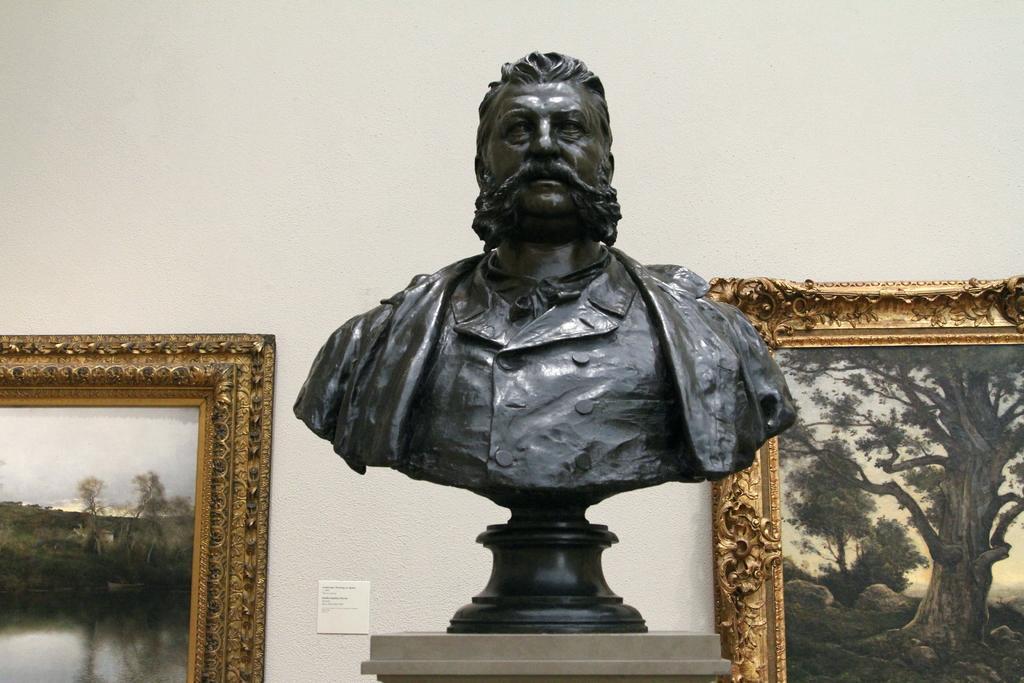Could you give a brief overview of what you see in this image? In this image we can see a sculpture on the stand and wall hangings attached to the wall. 